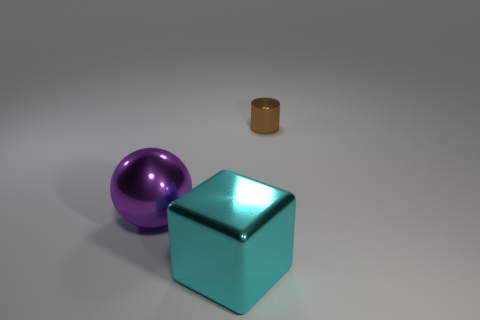Subtract all balls. How many objects are left? 2 Add 3 gray rubber cylinders. How many objects exist? 6 Subtract all cyan things. Subtract all tiny brown matte balls. How many objects are left? 2 Add 1 small objects. How many small objects are left? 2 Add 3 tiny cyan matte cylinders. How many tiny cyan matte cylinders exist? 3 Subtract 1 brown cylinders. How many objects are left? 2 